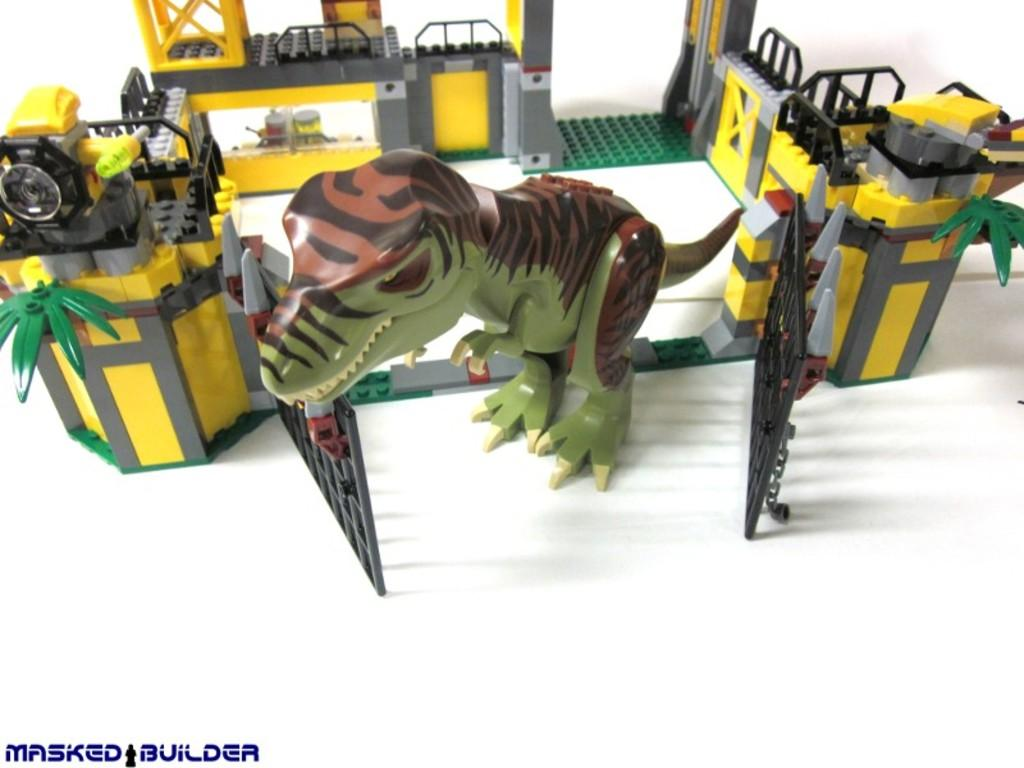What is the main subject in the center of the image? There are building blocks in the center of the image. What other type of object can be seen in the image? There is a toy in the image. Where is the text located in the image? The text is at the bottom of the image. How much sugar is required to fix the wrench in the image? There is no wrench present in the image, and therefore no sugar is required to fix it. 